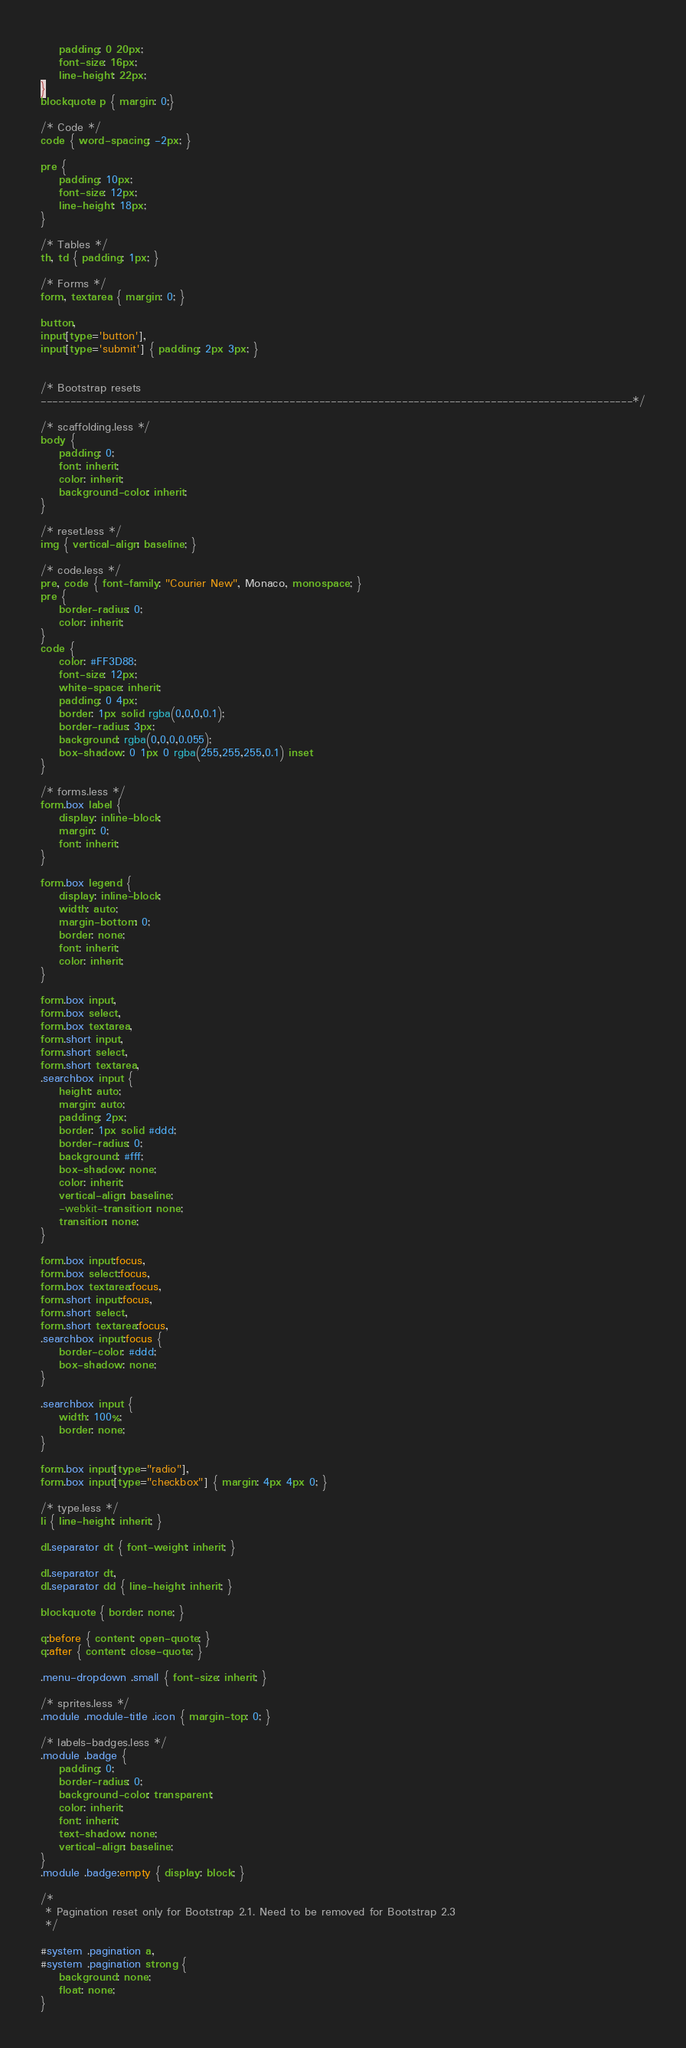Convert code to text. <code><loc_0><loc_0><loc_500><loc_500><_CSS_>	padding: 0 20px;
	font-size: 16px;
	line-height: 22px;
}
blockquote p { margin: 0;}

/* Code */
code { word-spacing: -2px; }

pre {
	padding: 10px;
	font-size: 12px;
	line-height: 18px;
}

/* Tables */
th, td { padding: 1px; }

/* Forms */
form, textarea { margin: 0; }

button,
input[type='button'],
input[type='submit'] { padding: 2px 3px; }


/* Bootstrap resets
----------------------------------------------------------------------------------------------------*/

/* scaffolding.less */
body {
	padding: 0;
	font: inherit;
	color: inherit;
	background-color: inherit;
}

/* reset.less */
img { vertical-align: baseline; }

/* code.less */
pre, code { font-family: "Courier New", Monaco, monospace; }
pre {
	border-radius: 0;
	color: inherit;
}
code {
	color: #FF3D88;
	font-size: 12px;
	white-space: inherit;
	padding: 0 4px;
	border: 1px solid rgba(0,0,0,0.1);
	border-radius: 3px;
	background: rgba(0,0,0,0.055);
	box-shadow: 0 1px 0 rgba(255,255,255,0.1) inset
}

/* forms.less */
form.box label {
	display: inline-block;
	margin: 0;
	font: inherit;
}

form.box legend {
	display: inline-block;
	width: auto;
	margin-bottom: 0;
	border: none;
	font: inherit;
	color: inherit;
}

form.box input,
form.box select,
form.box textarea,
form.short input,
form.short select,
form.short textarea,
.searchbox input {
	height: auto;
	margin: auto;
	padding: 2px;
	border: 1px solid #ddd;
	border-radius: 0;
	background: #fff;
	box-shadow: none;
	color: inherit;
	vertical-align: baseline;
	-webkit-transition: none;
	transition: none;
}

form.box input:focus,
form.box select:focus,
form.box textarea:focus,
form.short input:focus,
form.short select,
form.short textarea:focus,
.searchbox input:focus {
	border-color: #ddd;
	box-shadow: none;
}

.searchbox input {
	width: 100%;
	border: none;
}

form.box input[type="radio"], 
form.box input[type="checkbox"] { margin: 4px 4px 0; }

/* type.less */
li { line-height: inherit; }

dl.separator dt { font-weight: inherit; }

dl.separator dt,
dl.separator dd { line-height: inherit; }

blockquote { border: none; }

q:before { content: open-quote; }
q:after { content: close-quote; }

.menu-dropdown .small { font-size: inherit; }

/* sprites.less */
.module .module-title .icon { margin-top: 0; }

/* labels-badges.less */
.module .badge {
	padding: 0;
	border-radius: 0;
	background-color: transparent;
	color: inherit;
	font: inherit;
	text-shadow: none;
	vertical-align: baseline;
}
.module .badge:empty { display: block; }

/* 
 * Pagination reset only for Bootstrap 2.1. Need to be removed for Bootstrap 2.3
 */

#system .pagination a,
#system .pagination strong {
	background: none;
	float: none;
}</code> 